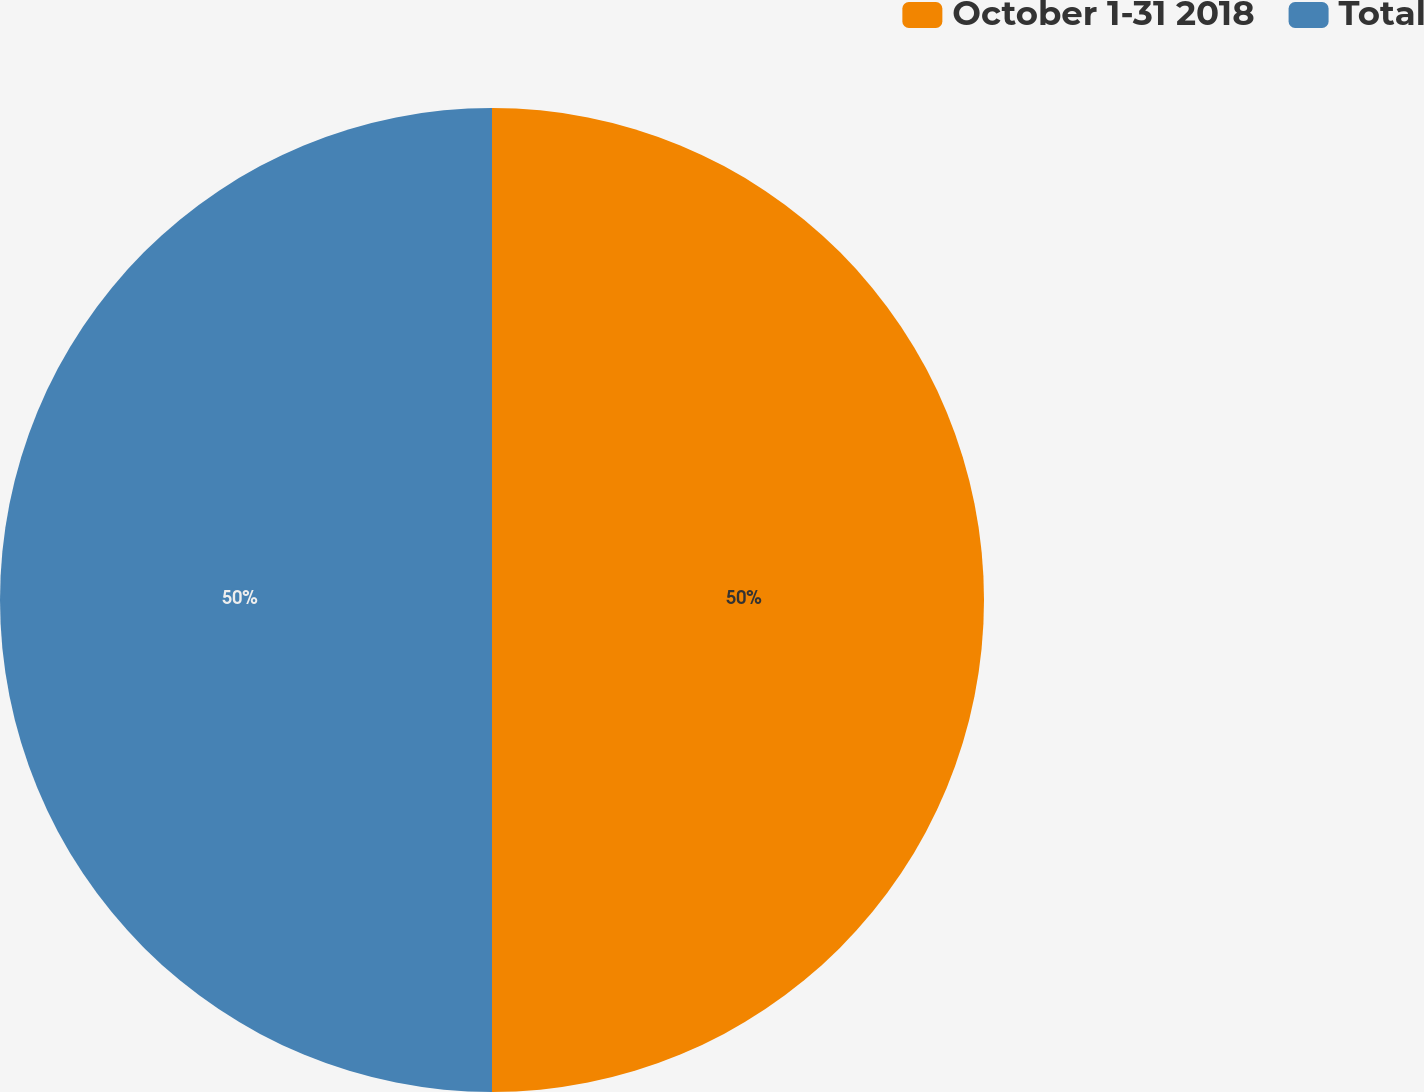Convert chart. <chart><loc_0><loc_0><loc_500><loc_500><pie_chart><fcel>October 1-31 2018<fcel>Total<nl><fcel>50.0%<fcel>50.0%<nl></chart> 